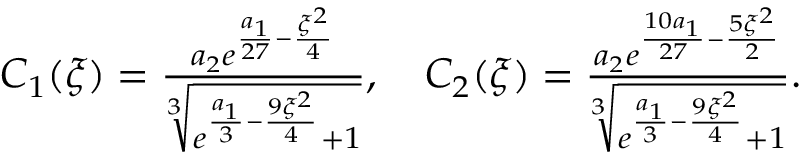Convert formula to latex. <formula><loc_0><loc_0><loc_500><loc_500>\begin{array} { r l } & { C _ { 1 } ( \xi ) = \frac { a _ { 2 } e ^ { \frac { a _ { 1 } } { 2 7 } - \frac { \xi ^ { 2 } } { 4 } } } { \sqrt { [ } 3 ] { e ^ { \frac { a _ { 1 } } { 3 } - \frac { 9 \xi ^ { 2 } } { 4 } } + 1 } } , \quad C _ { 2 } ( \xi ) = \frac { a _ { 2 } e ^ { \frac { 1 0 a _ { 1 } } { 2 7 } - \frac { 5 \xi ^ { 2 } } { 2 } } } { \sqrt { [ } 3 ] { e ^ { \frac { a _ { 1 } } { 3 } - \frac { 9 \xi ^ { 2 } } { 4 } } + 1 } } . } \end{array}</formula> 